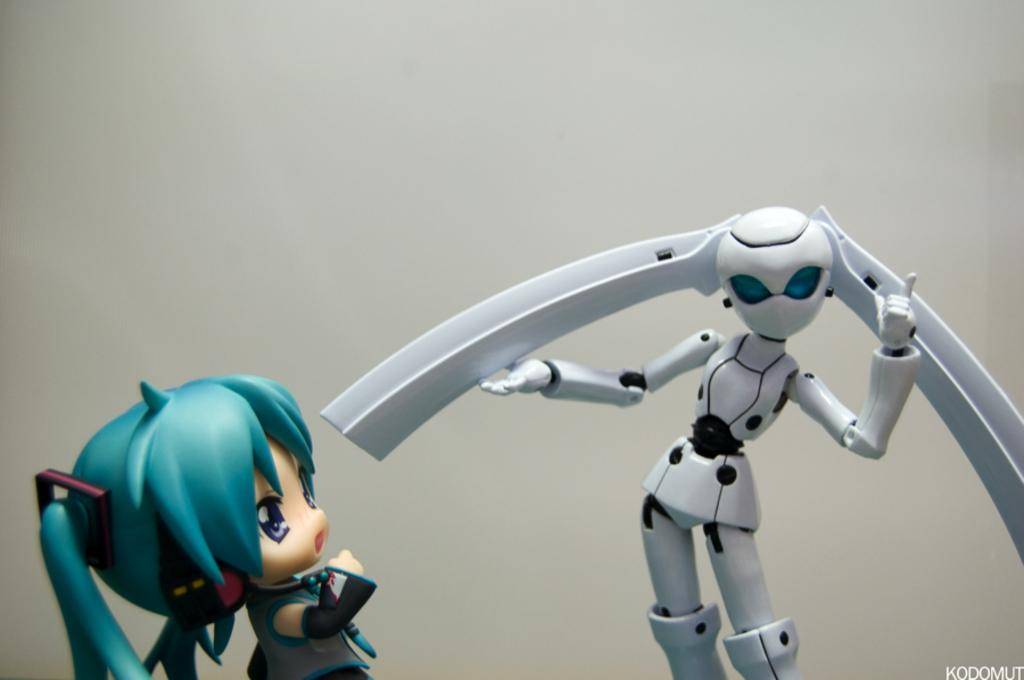How many toys can be seen in the image? There are two toys in the image. What is written or depicted on the bottom right side of the image? There is text on the bottom right side of the image. What color is the background of the image? The background of the image is white. What type of committee is shown discussing the toys in the image? There is no committee present in the image, and the toys are not being discussed. 